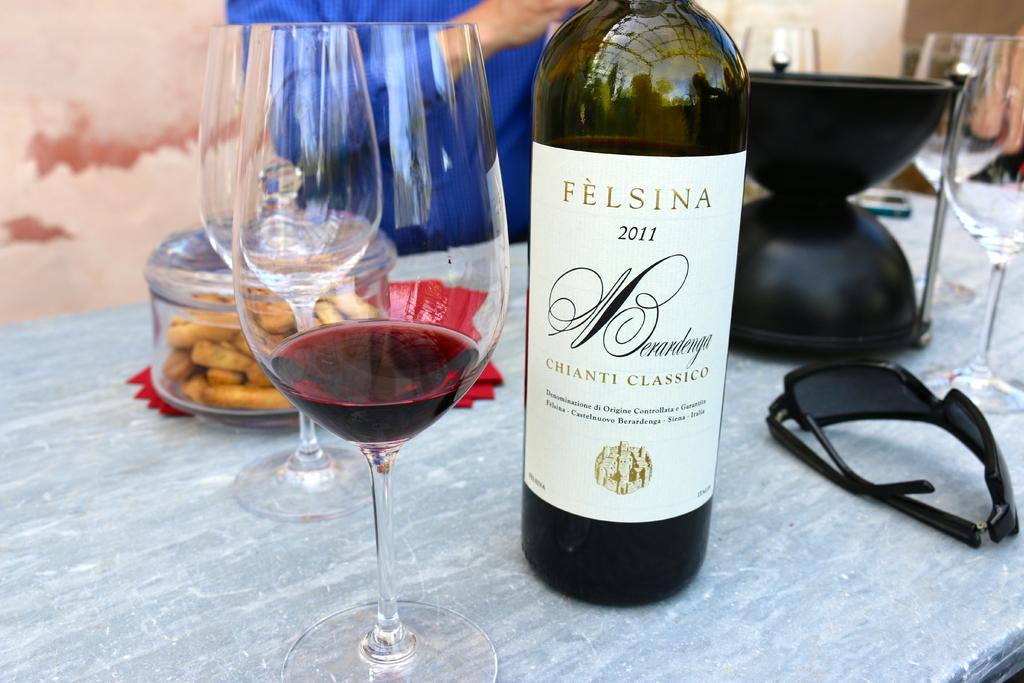Provide a one-sentence caption for the provided image. A table with wine glasses and a 2011 Felsina wine. 